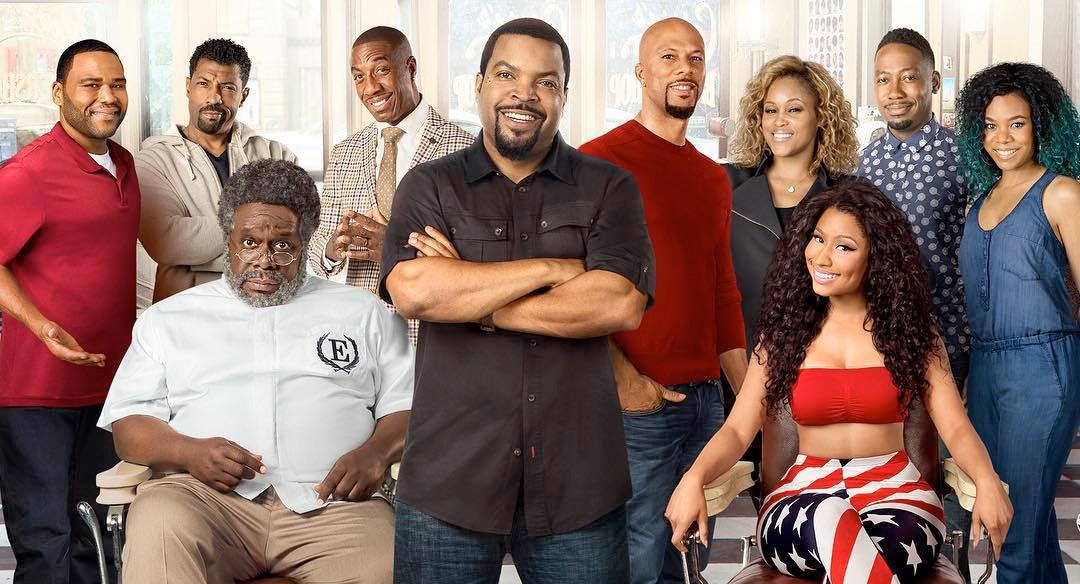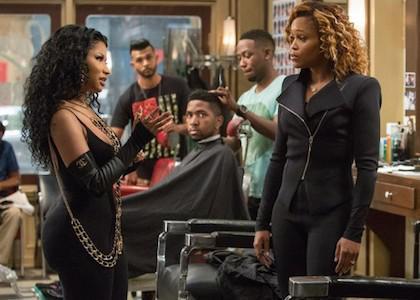The first image is the image on the left, the second image is the image on the right. Analyze the images presented: Is the assertion "The person in the right image furthest to the right has a bald scalp." valid? Answer yes or no. No. The first image is the image on the left, the second image is the image on the right. Evaluate the accuracy of this statement regarding the images: "There is at least one image of a man sitting in a barber chair.". Is it true? Answer yes or no. Yes. 